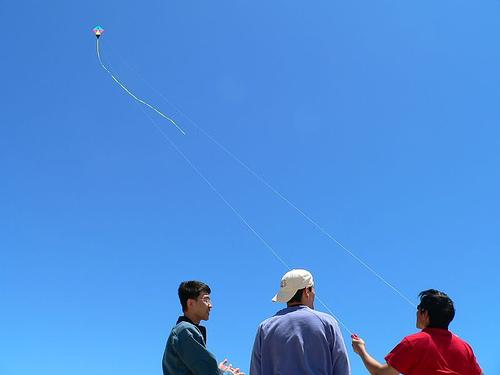Which color shirt does the person flying the kite wear? Please explain your reasoning. red. The person holding the strings to the kite has red on. 